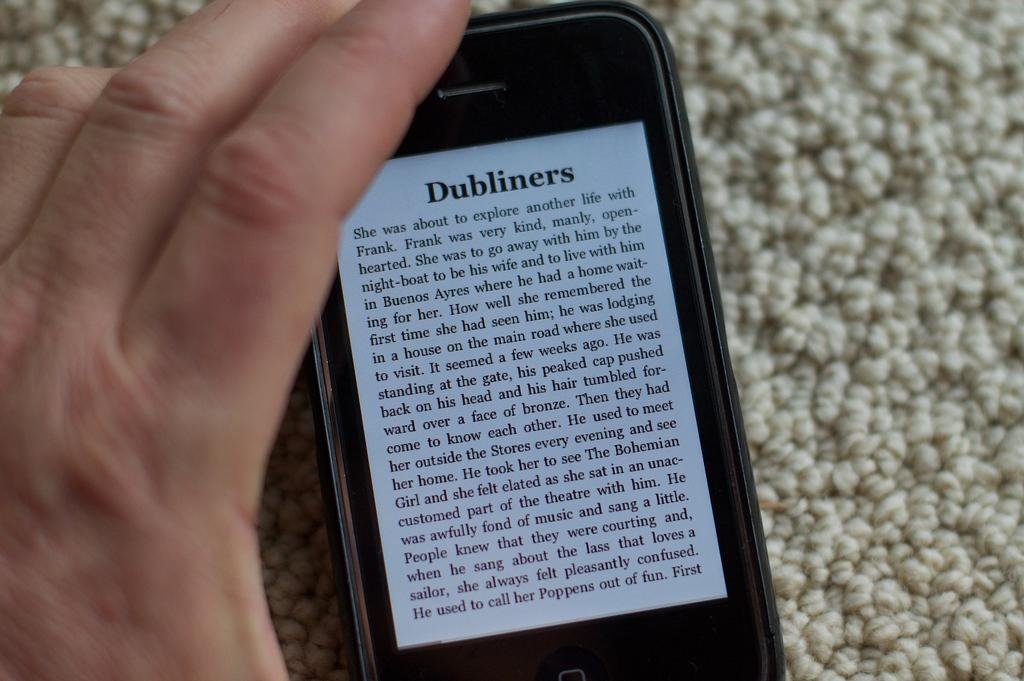<image>
Summarize the visual content of the image. A phone which is displaying a passage from the book Dubliners. 